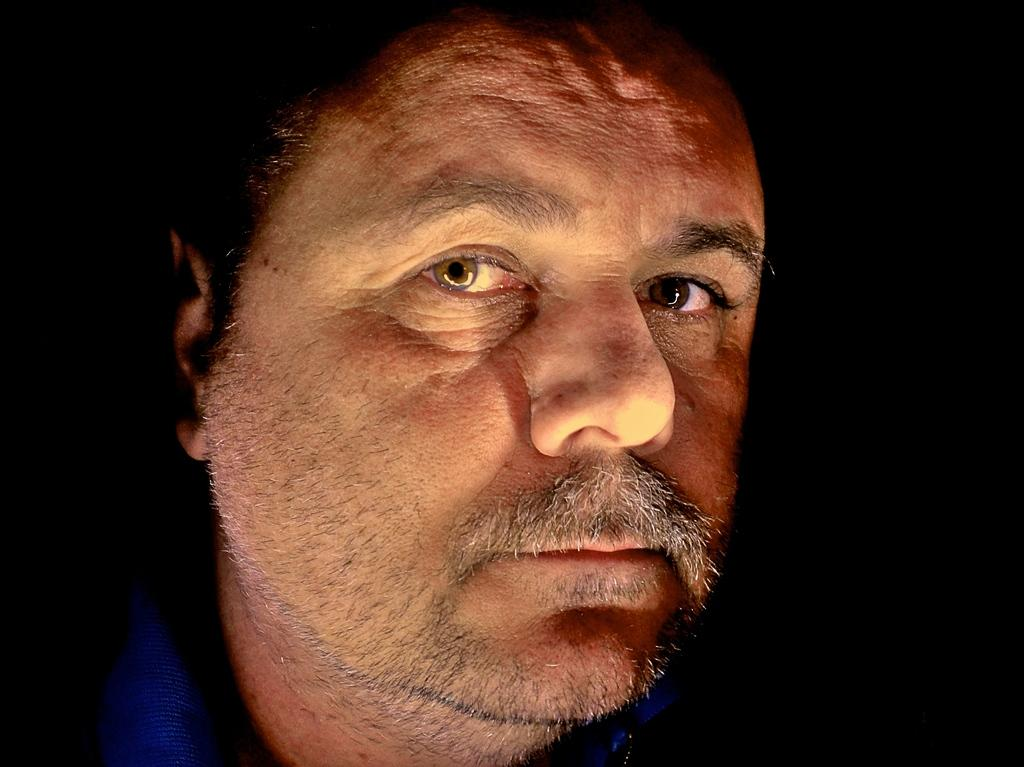What is the main subject of the image? The main subject of the image is the face of a man. Can you describe the background of the image? The background of the image is dark. What type of committee is meeting in the bedroom in the image? There is no bedroom or committee present in the image; it only features the face of a man with a dark background. 